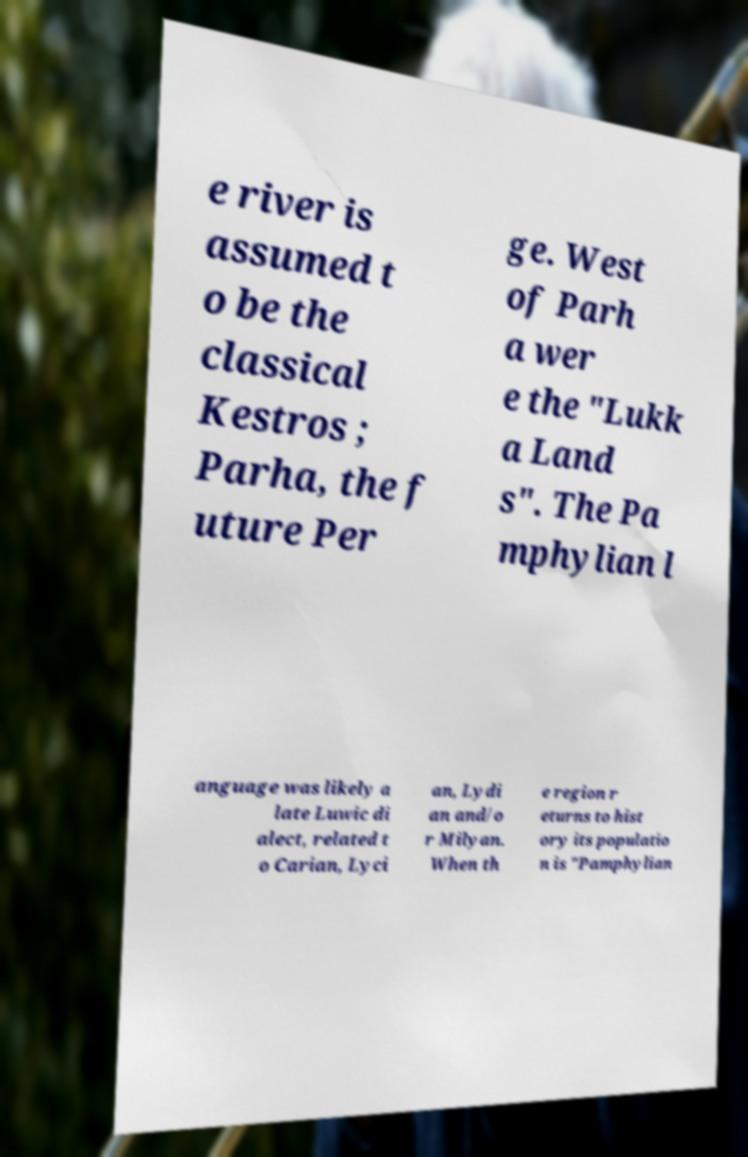Could you extract and type out the text from this image? e river is assumed t o be the classical Kestros ; Parha, the f uture Per ge. West of Parh a wer e the "Lukk a Land s". The Pa mphylian l anguage was likely a late Luwic di alect, related t o Carian, Lyci an, Lydi an and/o r Milyan. When th e region r eturns to hist ory its populatio n is "Pamphylian 